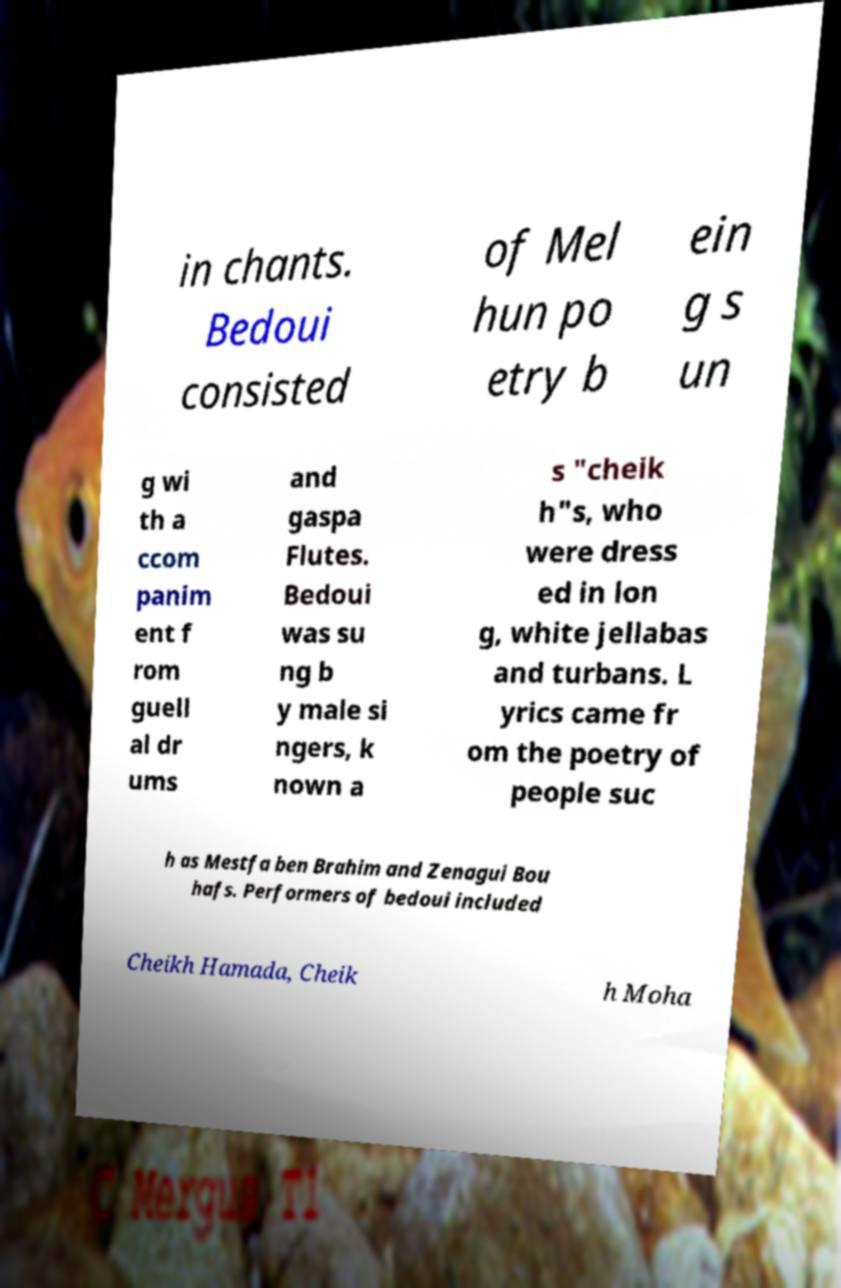What messages or text are displayed in this image? I need them in a readable, typed format. in chants. Bedoui consisted of Mel hun po etry b ein g s un g wi th a ccom panim ent f rom guell al dr ums and gaspa Flutes. Bedoui was su ng b y male si ngers, k nown a s "cheik h"s, who were dress ed in lon g, white jellabas and turbans. L yrics came fr om the poetry of people suc h as Mestfa ben Brahim and Zenagui Bou hafs. Performers of bedoui included Cheikh Hamada, Cheik h Moha 